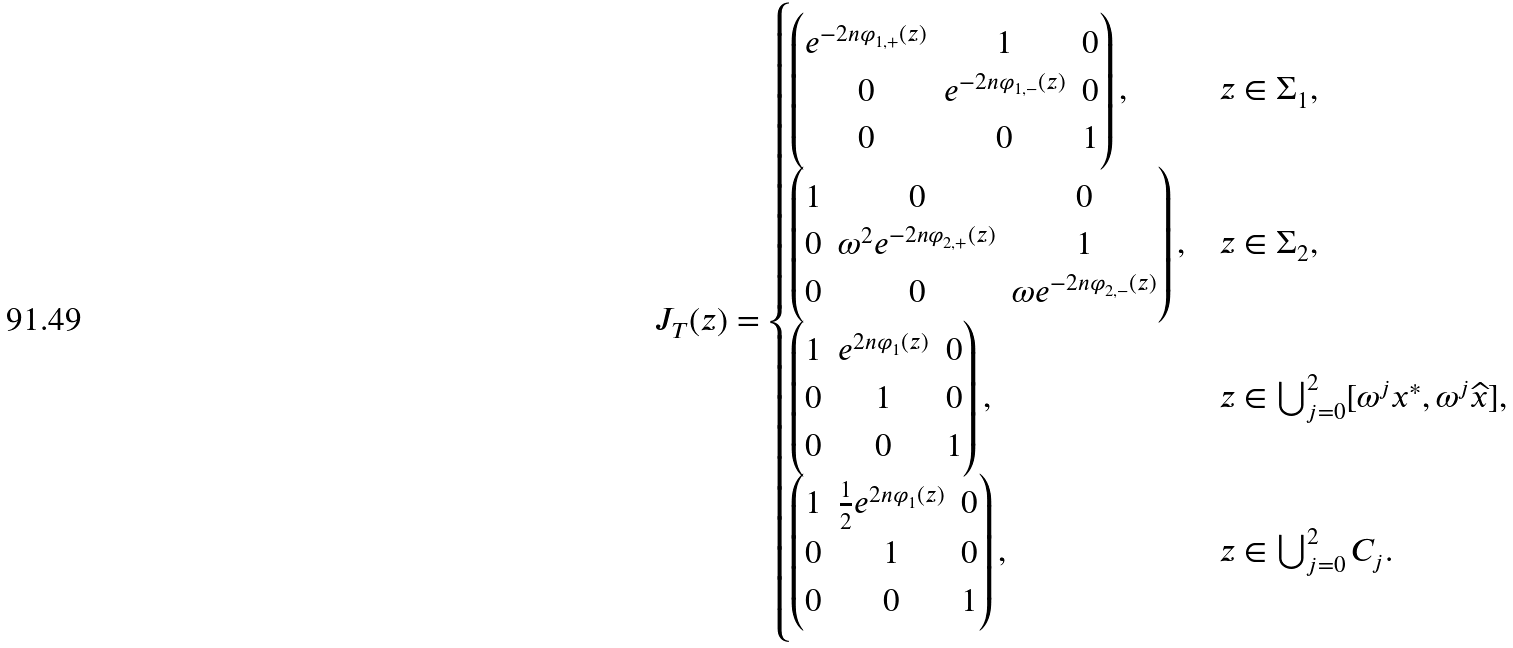Convert formula to latex. <formula><loc_0><loc_0><loc_500><loc_500>J _ { T } ( z ) = \begin{cases} \begin{pmatrix} e ^ { - 2 n \varphi _ { 1 , + } ( z ) } & 1 & 0 \\ 0 & e ^ { - 2 n \varphi _ { 1 , - } ( z ) } & 0 \\ 0 & 0 & 1 \end{pmatrix} , & z \in \Sigma _ { 1 } , \\ \begin{pmatrix} 1 & 0 & 0 \\ 0 & \omega ^ { 2 } e ^ { - 2 n \varphi _ { 2 , + } ( z ) } & 1 \\ 0 & 0 & \omega e ^ { - 2 n \varphi _ { 2 , - } ( z ) } \end{pmatrix} , & z \in \Sigma _ { 2 } , \\ \begin{pmatrix} 1 & e ^ { 2 n \varphi _ { 1 } ( z ) } & 0 \\ 0 & 1 & 0 \\ 0 & 0 & 1 \end{pmatrix} , & z \in \bigcup _ { j = 0 } ^ { 2 } [ \omega ^ { j } x ^ { * } , \omega ^ { j } \widehat { x } ] , \\ \begin{pmatrix} 1 & \frac { 1 } { 2 } e ^ { 2 n \varphi _ { 1 } ( z ) } & 0 \\ 0 & 1 & 0 \\ 0 & 0 & 1 \end{pmatrix} , & z \in \bigcup _ { j = 0 } ^ { 2 } C _ { j } . \end{cases}</formula> 